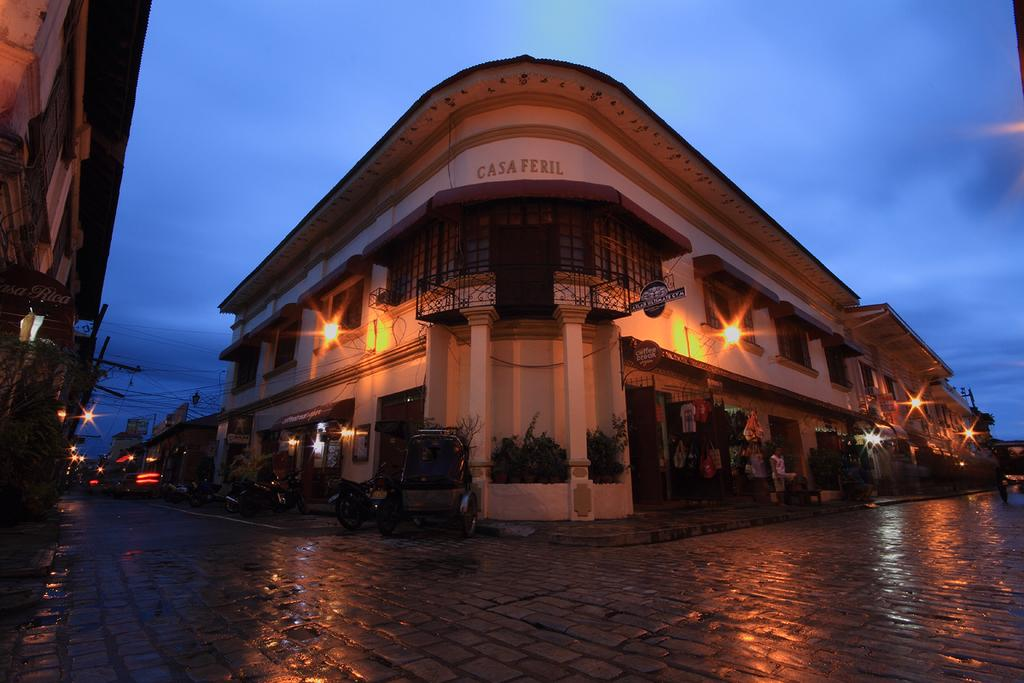What types of structures can be seen in the image? There are buildings in the image. What else can be found in the image besides buildings? There are plants, lights, poles, wires, a grille, vehicles, people, and boards visible in the image. Can you describe the sky in the background of the image? The sky is visible in the background of the image, and there are clouds present. What type of answer can be seen coiled around the trade in the image? There is no answer, coil, or trade present in the image. What type of trade is being conducted by the people in the image? There is no indication of any trade being conducted in the image; people are simply present alongside other objects and structures. 